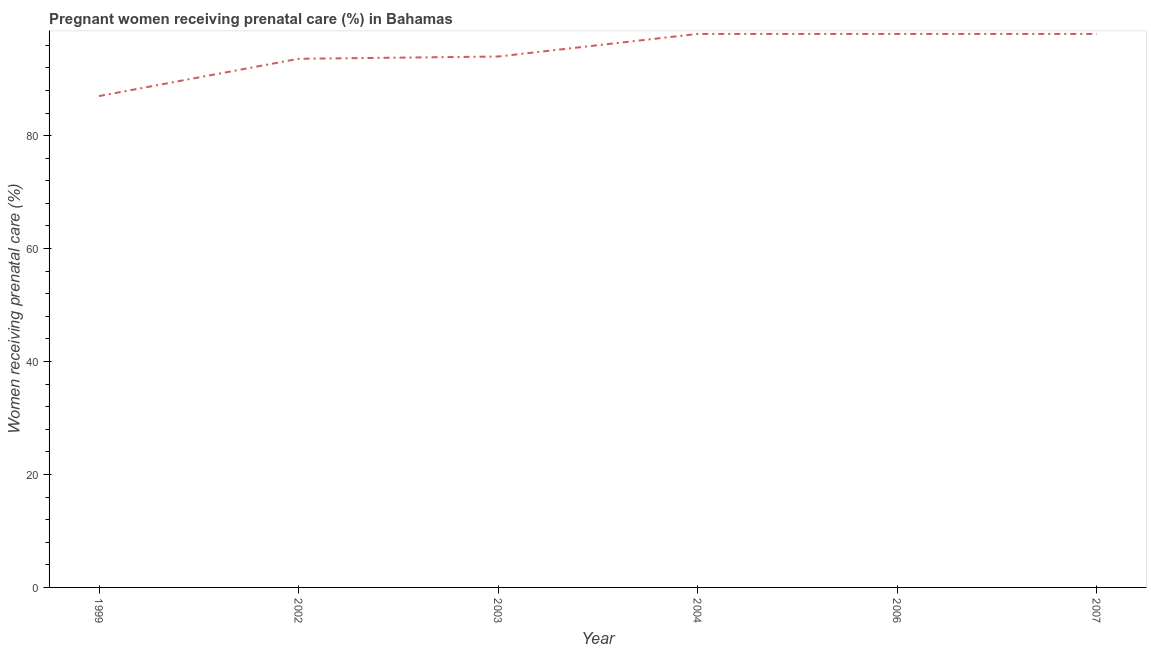What is the percentage of pregnant women receiving prenatal care in 2002?
Keep it short and to the point. 93.6. In which year was the percentage of pregnant women receiving prenatal care minimum?
Make the answer very short. 1999. What is the sum of the percentage of pregnant women receiving prenatal care?
Give a very brief answer. 568.6. What is the average percentage of pregnant women receiving prenatal care per year?
Offer a very short reply. 94.77. What is the median percentage of pregnant women receiving prenatal care?
Your answer should be compact. 96. What is the ratio of the percentage of pregnant women receiving prenatal care in 2002 to that in 2004?
Provide a succinct answer. 0.96. Is the percentage of pregnant women receiving prenatal care in 2002 less than that in 2006?
Ensure brevity in your answer.  Yes. Is the difference between the percentage of pregnant women receiving prenatal care in 2002 and 2004 greater than the difference between any two years?
Ensure brevity in your answer.  No. What is the difference between the highest and the second highest percentage of pregnant women receiving prenatal care?
Provide a short and direct response. 0. How many years are there in the graph?
Your answer should be compact. 6. Are the values on the major ticks of Y-axis written in scientific E-notation?
Your answer should be very brief. No. Does the graph contain any zero values?
Offer a very short reply. No. Does the graph contain grids?
Provide a short and direct response. No. What is the title of the graph?
Ensure brevity in your answer.  Pregnant women receiving prenatal care (%) in Bahamas. What is the label or title of the Y-axis?
Make the answer very short. Women receiving prenatal care (%). What is the Women receiving prenatal care (%) in 1999?
Provide a succinct answer. 87. What is the Women receiving prenatal care (%) of 2002?
Your answer should be very brief. 93.6. What is the Women receiving prenatal care (%) of 2003?
Your response must be concise. 94. What is the Women receiving prenatal care (%) of 2004?
Your response must be concise. 98. What is the Women receiving prenatal care (%) in 2006?
Your answer should be compact. 98. What is the difference between the Women receiving prenatal care (%) in 1999 and 2003?
Keep it short and to the point. -7. What is the difference between the Women receiving prenatal care (%) in 1999 and 2004?
Offer a very short reply. -11. What is the difference between the Women receiving prenatal care (%) in 1999 and 2007?
Your answer should be compact. -11. What is the difference between the Women receiving prenatal care (%) in 2002 and 2003?
Offer a terse response. -0.4. What is the difference between the Women receiving prenatal care (%) in 2003 and 2004?
Offer a terse response. -4. What is the difference between the Women receiving prenatal care (%) in 2003 and 2007?
Provide a short and direct response. -4. What is the difference between the Women receiving prenatal care (%) in 2004 and 2006?
Make the answer very short. 0. What is the ratio of the Women receiving prenatal care (%) in 1999 to that in 2002?
Give a very brief answer. 0.93. What is the ratio of the Women receiving prenatal care (%) in 1999 to that in 2003?
Give a very brief answer. 0.93. What is the ratio of the Women receiving prenatal care (%) in 1999 to that in 2004?
Your answer should be compact. 0.89. What is the ratio of the Women receiving prenatal care (%) in 1999 to that in 2006?
Make the answer very short. 0.89. What is the ratio of the Women receiving prenatal care (%) in 1999 to that in 2007?
Your response must be concise. 0.89. What is the ratio of the Women receiving prenatal care (%) in 2002 to that in 2004?
Make the answer very short. 0.95. What is the ratio of the Women receiving prenatal care (%) in 2002 to that in 2006?
Make the answer very short. 0.95. What is the ratio of the Women receiving prenatal care (%) in 2002 to that in 2007?
Offer a very short reply. 0.95. What is the ratio of the Women receiving prenatal care (%) in 2003 to that in 2004?
Ensure brevity in your answer.  0.96. What is the ratio of the Women receiving prenatal care (%) in 2003 to that in 2006?
Provide a succinct answer. 0.96. What is the ratio of the Women receiving prenatal care (%) in 2003 to that in 2007?
Provide a short and direct response. 0.96. What is the ratio of the Women receiving prenatal care (%) in 2004 to that in 2006?
Make the answer very short. 1. What is the ratio of the Women receiving prenatal care (%) in 2004 to that in 2007?
Provide a short and direct response. 1. What is the ratio of the Women receiving prenatal care (%) in 2006 to that in 2007?
Provide a succinct answer. 1. 